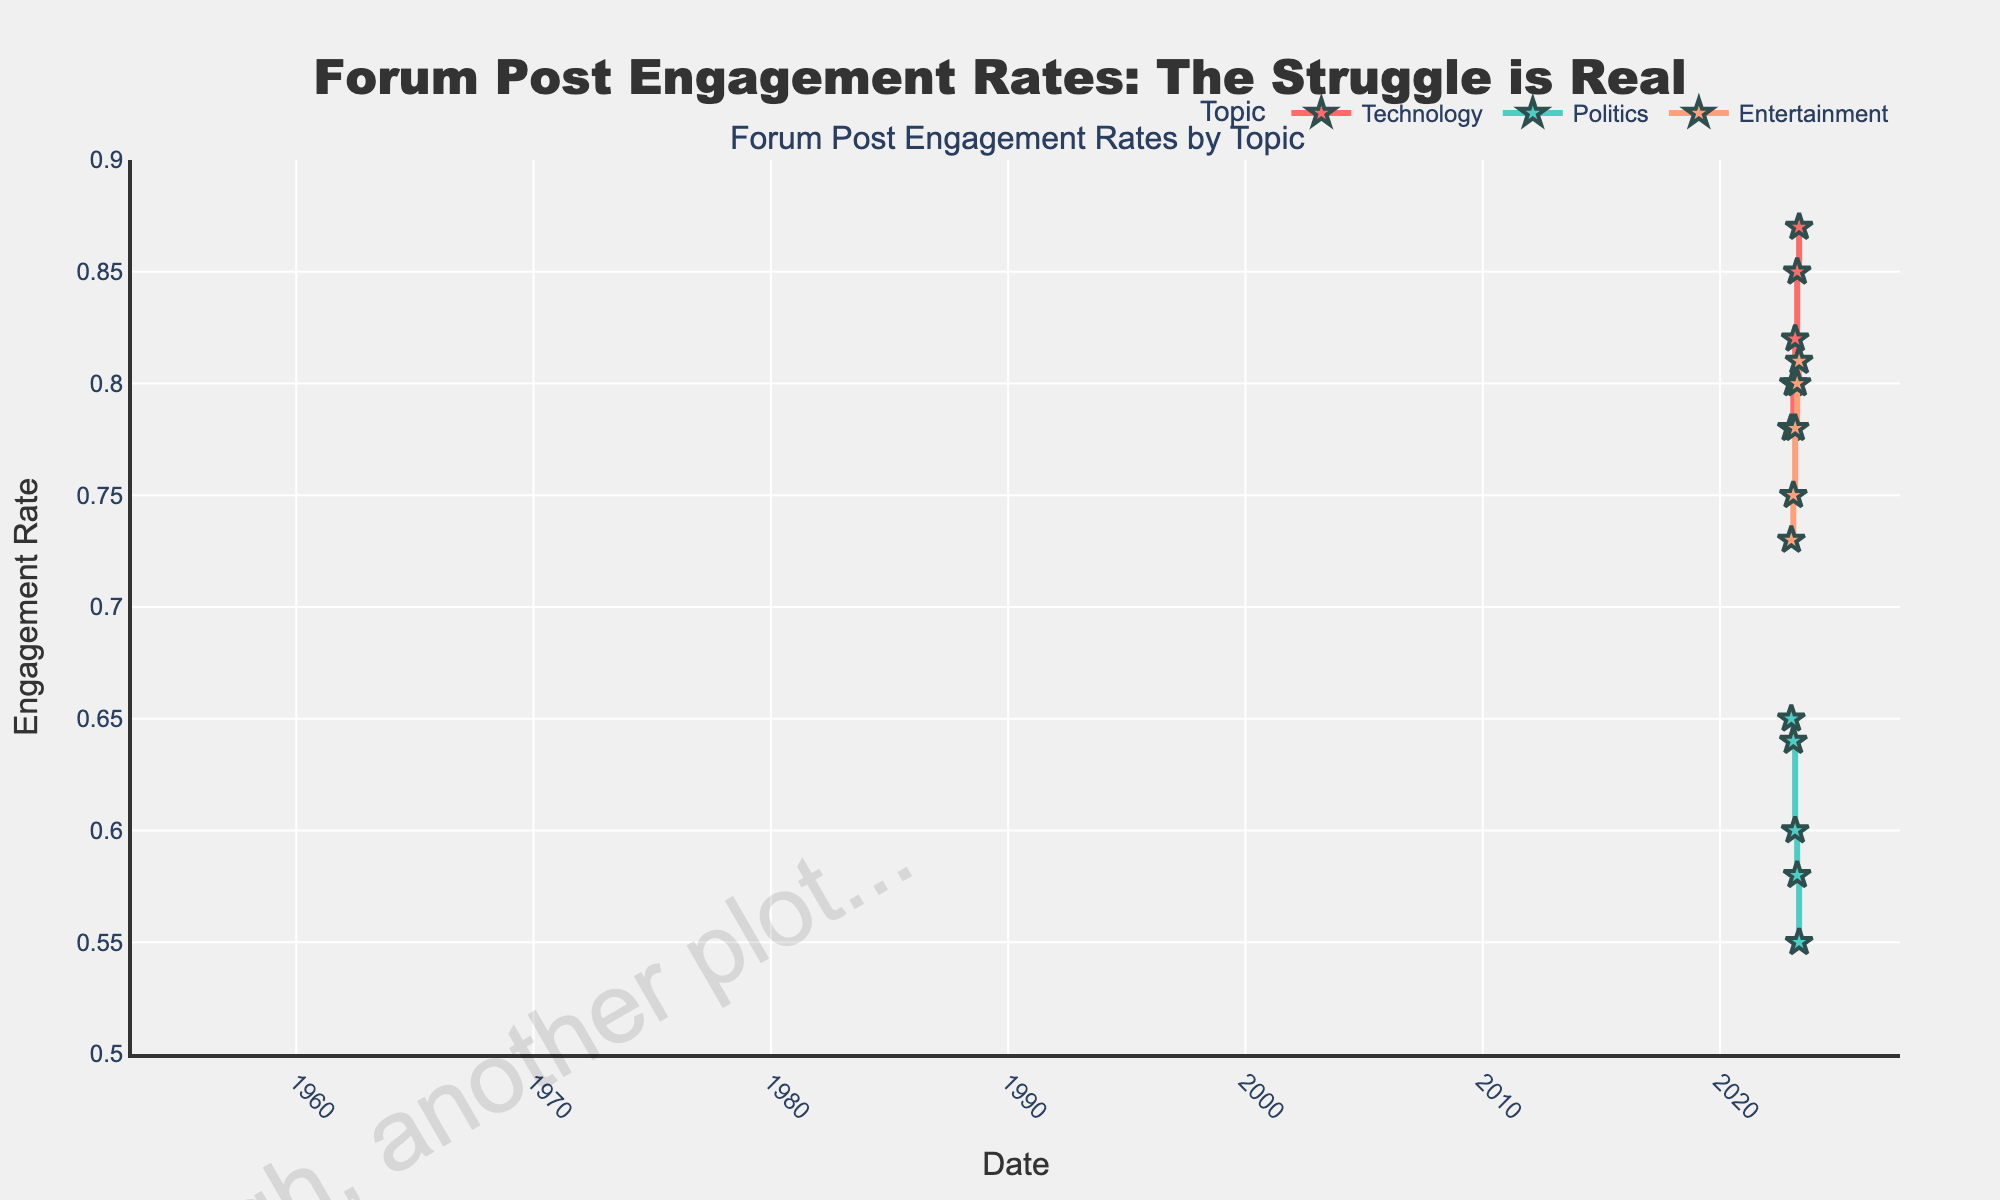What's the title of the plot? The title is usually located at the top of the plot. Here, it reads "Forum Post Engagement Rates: The Struggle is Real".
Answer: Forum Post Engagement Rates: The Struggle is Real What is the engagement rate for Technology on 2023-02-01? Find the point on the plot corresponding to Technology on 2023-02-01 and read its engagement rate. It falls at 0.80.
Answer: 0.80 Which topic shows the most significant decrease in engagement rate over time? Compare the slopes of the stair plots for each topic. Politics shows a significant decrease going from 0.65 to 0.55 from 2023-01-01 to 2023-05-01.
Answer: Politics What are the dates and engagement rates for the Entertainment topic? Look at the Entertainment plot and list all the dates along with their corresponding engagement rates: 2023-01-01 (0.73), 2023-02-01 (0.75), 2023-03-01 (0.78), 2023-04-01 (0.80), 2023-05-01 (0.81).
Answer: 2023-01-01 (0.73), 2023-02-01 (0.75), 2023-03-01 (0.78), 2023-04-01 (0.80), 2023-05-01 (0.81) Which topic had the highest engagement rate on 2023-04-01? Check the engagement rates of all topics on 2023-04-01. Technology is the highest with an engagement rate of 0.85.
Answer: Technology Calculate the average engagement rate for Technology over the given period. Add up all the engagement rates for Technology (0.78, 0.80, 0.82, 0.85, 0.87) and divide by the number of points, which is 5. (0.78 + 0.80 + 0.82 + 0.85 + 0.87) / 5 = 4.12 / 5 = 0.824
Answer: 0.824 Which topic remained relatively stable in its engagement rate trend over the months? Look for the topic with the least variation in engagement rates. Entertainment changed only from 0.73 to 0.81, which is relatively stable compared to the others.
Answer: Entertainment What is the range of engagement rates for Politics from 2023-01-01 to 2023-05-01? Identify the maximum and minimum engagement rates for Politics. The max is 0.65 (2023-01-01) and the min is 0.55 (2023-05-01). The range is 0.65 - 0.55 = 0.10.
Answer: 0.10 Which topic had the lowest engagement rate on any given date? Find the lowest point on the plots. Politics had the lowest engagement rate of 0.55 on 2023-05-01.
Answer: Politics 